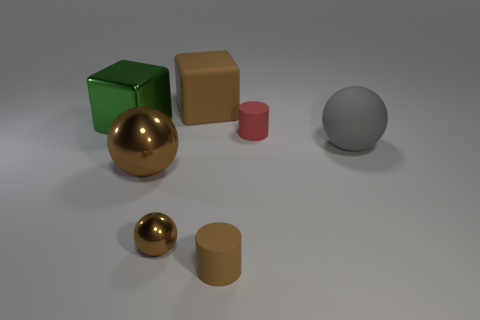There is a large ball that is the same material as the large brown block; what is its color?
Provide a short and direct response. Gray. There is a cylinder right of the matte thing that is in front of the sphere to the right of the small red object; what is its size?
Keep it short and to the point. Small. Is the number of tiny objects less than the number of brown objects?
Provide a short and direct response. Yes. The large rubber object that is the same shape as the tiny metallic thing is what color?
Make the answer very short. Gray. There is a tiny rubber cylinder in front of the small ball that is in front of the gray matte ball; is there a ball right of it?
Make the answer very short. Yes. Do the small metal thing and the gray object have the same shape?
Keep it short and to the point. Yes. Are there fewer brown spheres that are on the left side of the tiny metal sphere than metallic things?
Make the answer very short. Yes. There is a big matte thing that is in front of the big rubber thing that is behind the big metallic thing that is behind the large gray sphere; what is its color?
Offer a very short reply. Gray. How many shiny objects are either balls or tiny brown things?
Provide a short and direct response. 2. Do the rubber block and the red rubber cylinder have the same size?
Give a very brief answer. No. 